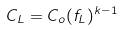<formula> <loc_0><loc_0><loc_500><loc_500>C _ { L } = C _ { o } ( f _ { L } ) ^ { k - 1 }</formula> 